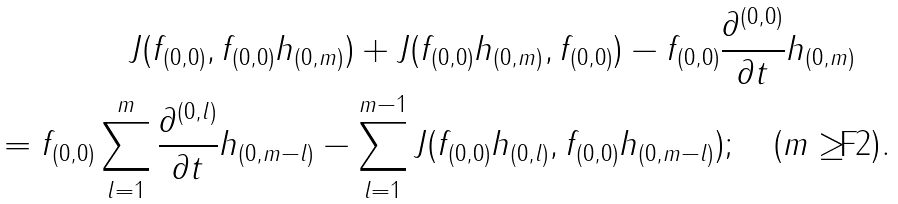Convert formula to latex. <formula><loc_0><loc_0><loc_500><loc_500>J ( f _ { ( 0 , 0 ) } , f _ { ( 0 , 0 ) } h _ { ( 0 , m ) } ) + J ( f _ { ( 0 , 0 ) } h _ { ( 0 , m ) } , f _ { ( 0 , 0 ) } ) - f _ { ( 0 , 0 ) } \frac { \partial ^ { ( 0 , 0 ) } } { \partial t } h _ { ( 0 , m ) } \quad \\ = f _ { ( 0 , 0 ) } \sum _ { l = 1 } ^ { m } \frac { \partial ^ { ( 0 , l ) } } { \partial t } h _ { ( 0 , m - l ) } - \sum _ { l = 1 } ^ { m - 1 } J ( f _ { ( 0 , 0 ) } h _ { ( 0 , l ) } , f _ { ( 0 , 0 ) } h _ { ( 0 , m - l ) } ) ; \quad ( m \geq 2 ) .</formula> 